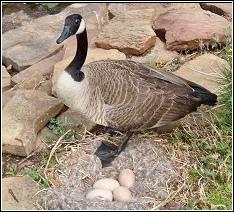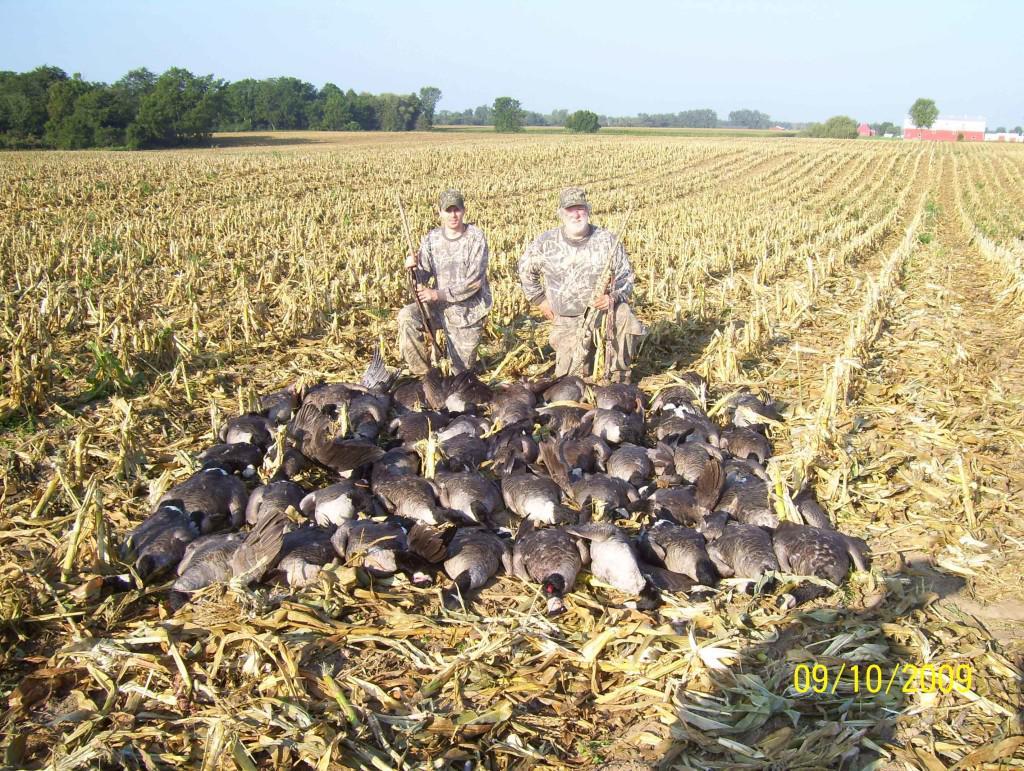The first image is the image on the left, the second image is the image on the right. Examine the images to the left and right. Is the description "There are more birds in the right image than in the left." accurate? Answer yes or no. Yes. 